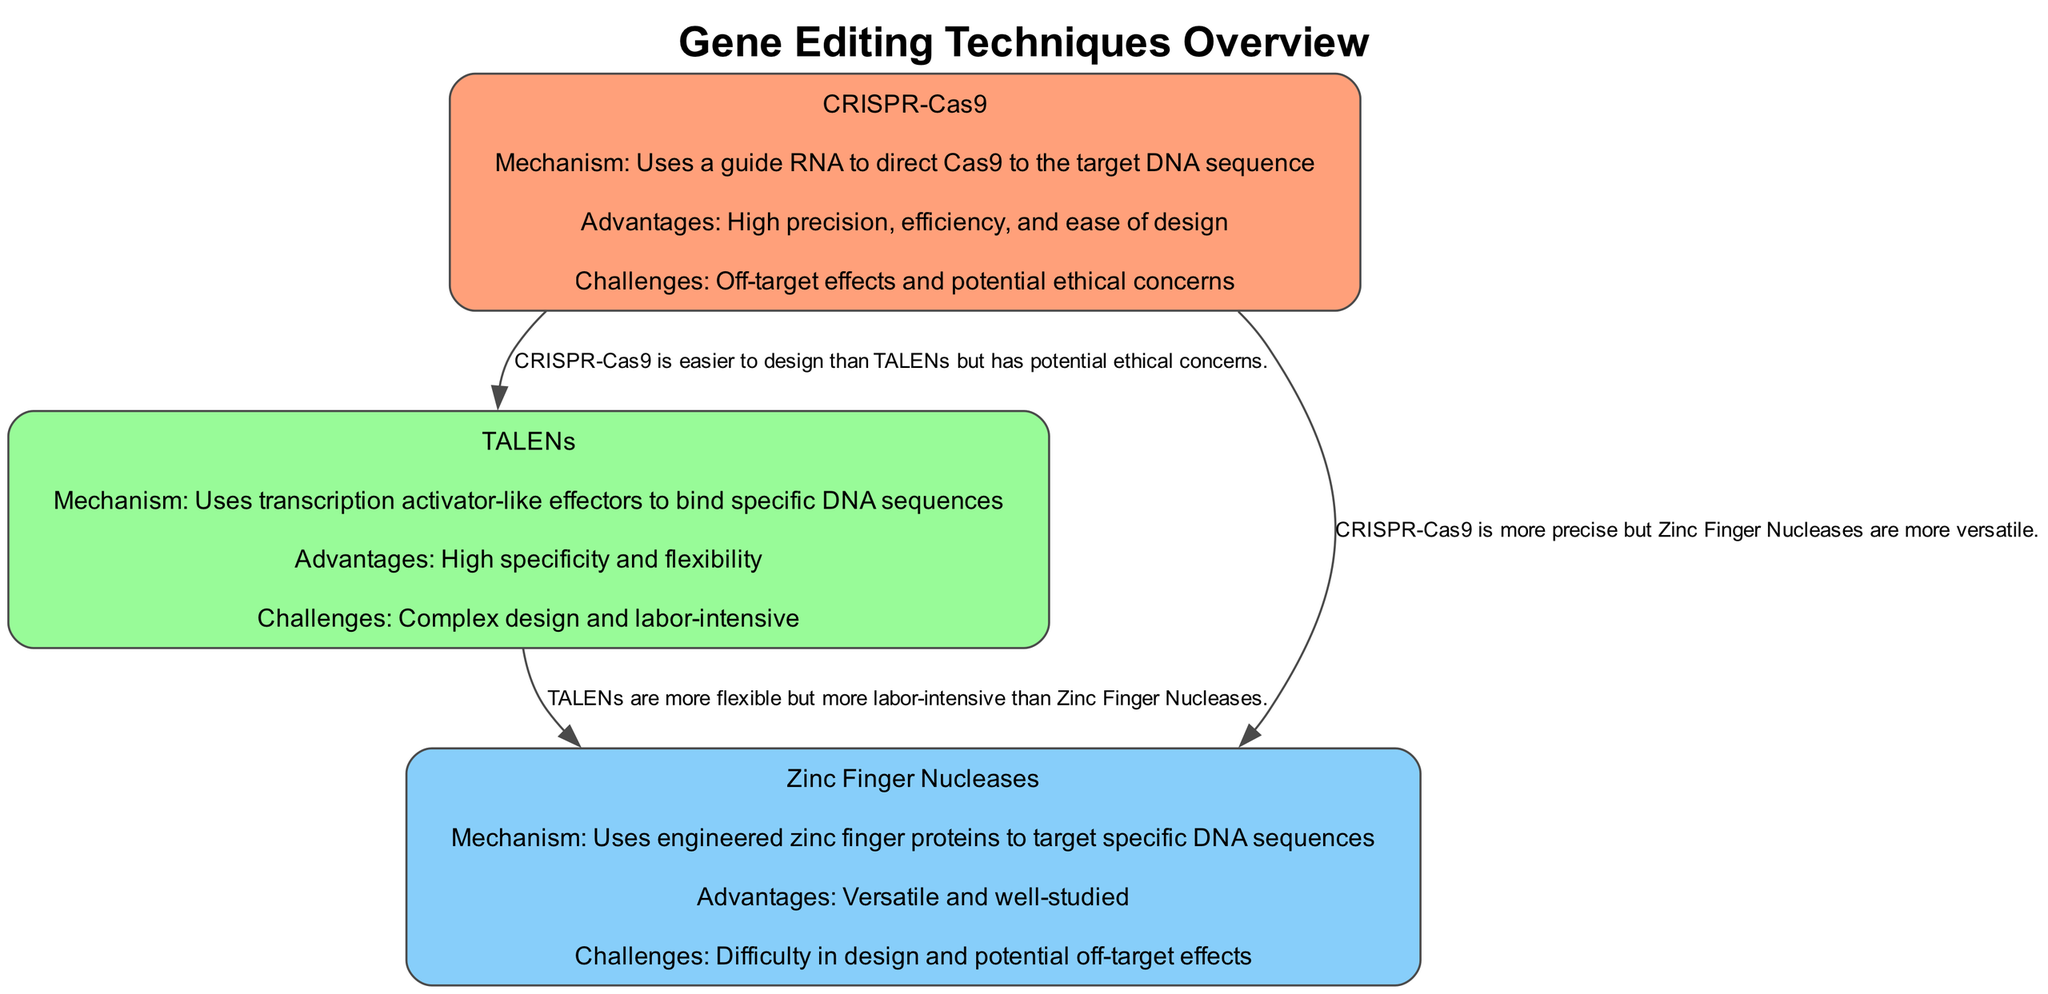What are the three gene editing techniques illustrated in the diagram? The diagram lists three techniques: CRISPR-Cas9, TALENs, and Zinc Finger Nucleases. They are explicitly mentioned as the labels of the nodes in the diagram.
Answer: CRISPR-Cas9, TALENs, Zinc Finger Nucleases What mechanism does CRISPR-Cas9 use? According to the diagram, CRISPR-Cas9 uses a guide RNA to direct Cas9 to the target DNA sequence, which is detailed in the mechanism section of the CRISPR node.
Answer: Uses a guide RNA to direct Cas9 to the target DNA sequence What is one advantage of using TALENs? The diagram specifies that TALENs offer high specificity as an advantage, clearly listed as part of the node details for TALENs.
Answer: High specificity How many types of comparisons are made in the diagram? The diagram shows three edges, each representing a comparison between different gene editing techniques (CRISPR-Cas9 vs TALENs, CRISPR-Cas9 vs Zinc Finger Nucleases, TALENs vs Zinc Finger Nucleases). Thus, there are three comparisons.
Answer: 3 What is a significant challenge associated with CRISPR-Cas9? The diagram lists off-target effects and potential ethical concerns as challenges for CRISPR-Cas9, found in the challenges section of the CRISPR node's details.
Answer: Off-target effects and potential ethical concerns Which gene editing technique is described as "labor-intensive"? The node for TALENs in the diagram identifies the challenge of being 'labor-intensive,' indicating it requires significant manual effort in its design and implementation.
Answer: Labor-intensive How does CRISPR-Cas9 compare to Zinc Finger Nucleases in terms of precision? The edge between CRISPR-Cas9 and Zinc Finger Nucleases states that CRISPR-Cas9 is more precise than Zinc Finger Nucleases, directly comparing their precision levels indicated in the details.
Answer: More precise What aspect differentiates TALENs from Zinc Finger Nucleases? The diagram notes that TALENs are more flexible compared to Zinc Finger Nucleases, highlighting a key difference between the two in the comparison edge.
Answer: More flexible What is a notable challenge for Zinc Finger Nucleases, as indicated in the diagram? The diagram specifically mentions the difficulty in design as a challenge for Zinc Finger Nucleases, explicitly noted in the challenges section of its node details.
Answer: Difficulty in design 